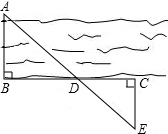Can you explain how to apply the findings from the given image to solve similar problems in different contexts? Certainly! The principles demonstrated in the image can generalize to solve similar problems. For instance, if you wanted to measure distance across a canyon or a building height using a base length on the ground, you can replicate the triangulation method shown. By selecting strategic points on the ground and applying similar triangles and the Pythagorean theorem, you can calculate distances or heights without directly accessing all points involved. This approach is invaluable in fields like surveying, construction, and even astronomy for indirect measurements. 